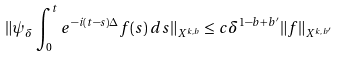<formula> <loc_0><loc_0><loc_500><loc_500>\| \psi _ { \delta } \int _ { 0 } ^ { t } e ^ { - i ( t - s ) \Delta } f ( s ) \, d s \| _ { X ^ { k , b } } \leq c \delta ^ { 1 - b + b ^ { \prime } } \| f \| _ { X ^ { k , b ^ { \prime } } }</formula> 